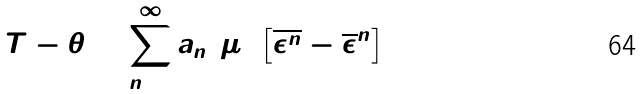<formula> <loc_0><loc_0><loc_500><loc_500>T - \theta = \sum _ { n = 2 } ^ { \infty } a _ { n } ( \mu ) \left [ { \overline { \epsilon ^ { n } } } - { \overline { \epsilon } } ^ { n } \right ]</formula> 